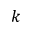Convert formula to latex. <formula><loc_0><loc_0><loc_500><loc_500>k</formula> 